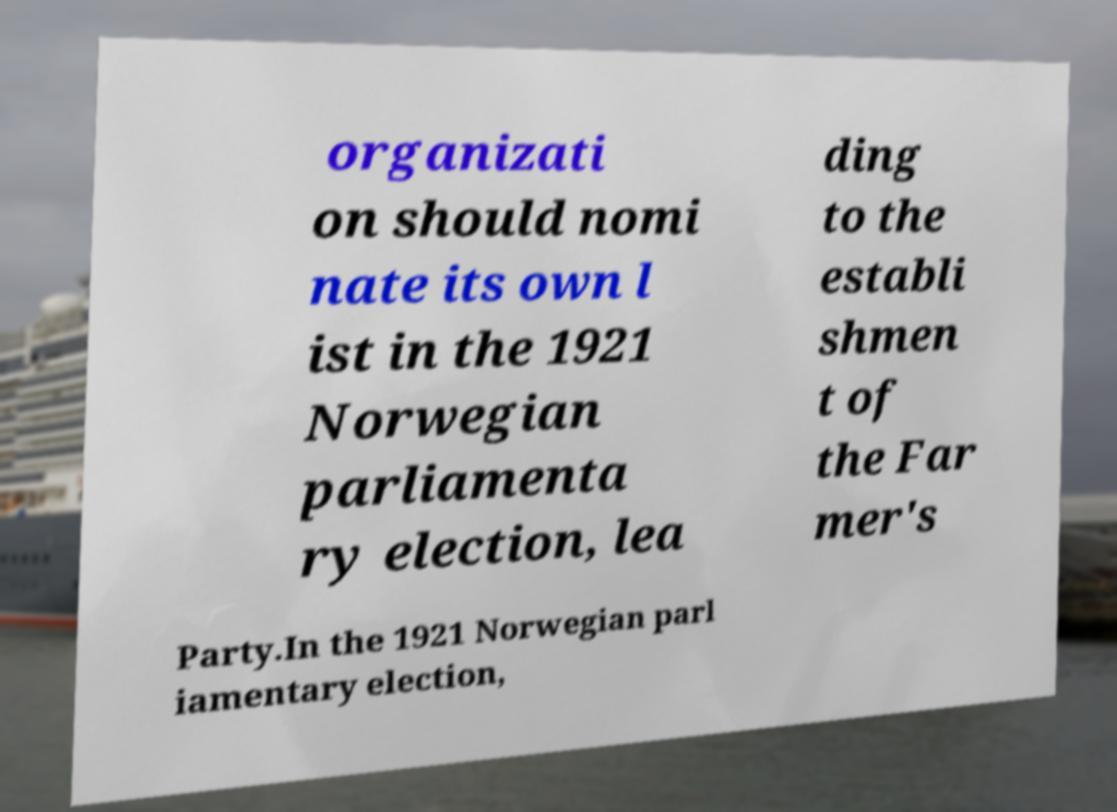For documentation purposes, I need the text within this image transcribed. Could you provide that? organizati on should nomi nate its own l ist in the 1921 Norwegian parliamenta ry election, lea ding to the establi shmen t of the Far mer's Party.In the 1921 Norwegian parl iamentary election, 